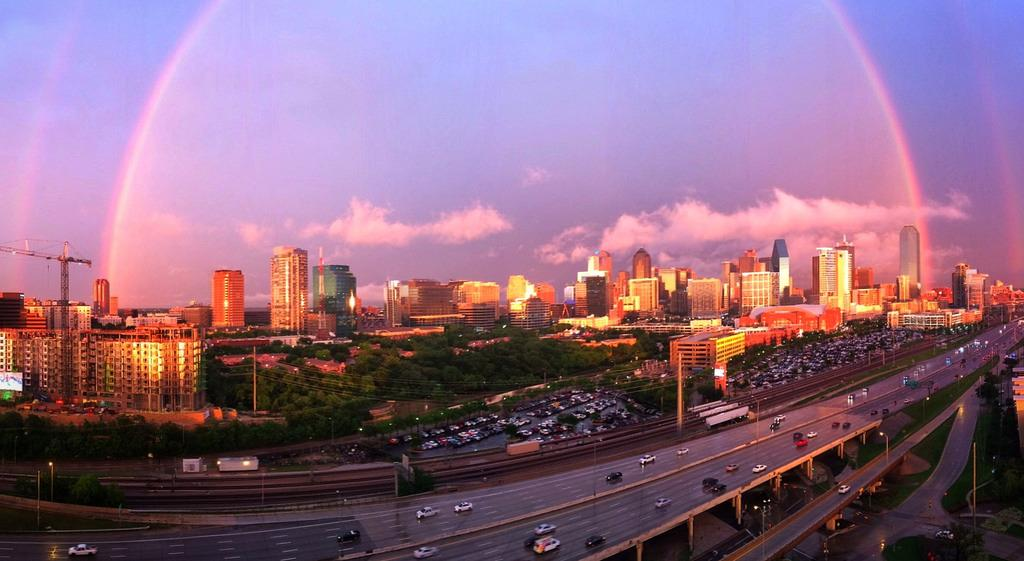What types of objects can be seen in the image? There are vehicles, trees, buildings, lights, a crane, and poles in the image. Can you describe the natural elements in the image? There are trees and clouds in the image. Where is the crane located in the image? The crane is on the left side of the image. What type of wood is used to make the face of the driver in the image? There is no driver or face present in the image, so it is not possible to determine the type of wood used. 